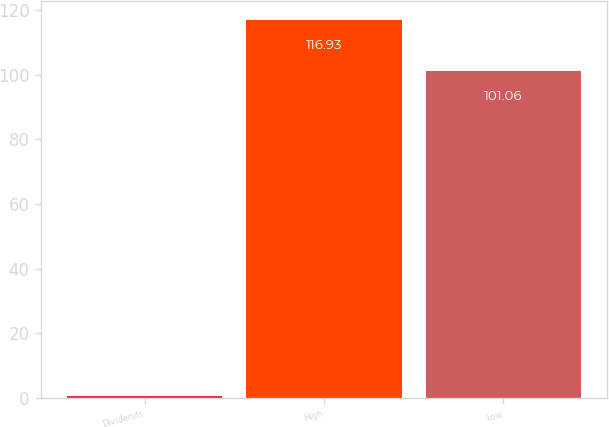<chart> <loc_0><loc_0><loc_500><loc_500><bar_chart><fcel>Dividends<fcel>High<fcel>Low<nl><fcel>0.6<fcel>116.93<fcel>101.06<nl></chart> 